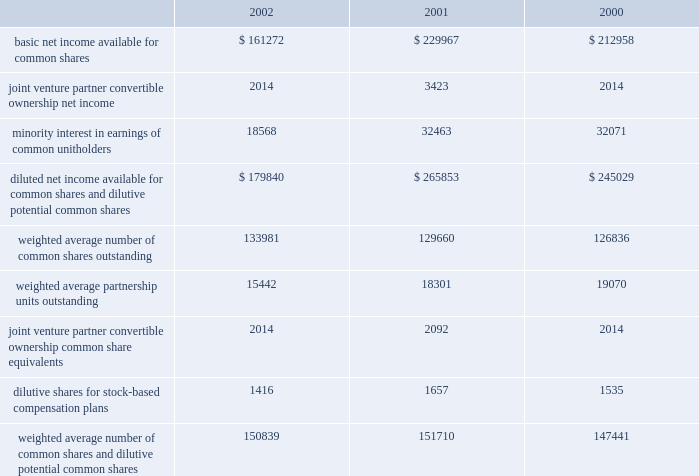D u k e r e a l t y c o r p o r a t i o n 2 8 2 0 0 2 a n n u a l r e p o r t notes to consolidated financial statements the company recognizes income on long-term construction contracts where the company serves as a general contractor on the percentage of completion method .
Using this method , profits are recorded on the basis of the company 2019s estimates of the percentage of completion of individual contracts , commencing when progress reaches a point where experience is sufficient to estimate final results with reasonable accuracy .
That portion of the estimated earnings is accrued on the basis of the company 2019s estimates of the percentage of completion based on contract expenditures incurred and work performed .
Property sales gains from sales of depreciated property are recognized in accordance with statement of financial accounting standards ( 201csfas 201d ) no .
66 , and are included in earnings from sales of land and depreciable property dispositions , net of impairment adjustment , in the statement of operations if identified as held for sale prior to adoption of sfas 144 and in discontinued operations if identified as held for sale after adoption of sfas 144 .
Gains or losses from the sale of property which is considered held for sale in dclp are recognized in accordance with sfas 66 and are included in construction management and development activity income in the statement of operations .
Net income per common share basic net income per common share is computed by dividing net income available for common shares by the weighted average number of common shares outstanding for the period .
Diluted net income per share is computed by dividing the sum of net income available for common shares and minority interest in earnings of unitholders , by the sum of the weighted average number of common shares and units outstanding and dilutive potential common shares for the period .
The table reconciles the components of basic and diluted net income per share ( in thousands ) : the series d convertible preferred stock and the series g convertible preferred limited partner units were anti-dilutive for the years ended december 31 , 2002 , 2001 and 2000 ; therefore , no conversion to common shares is included in weighted dilutive potential common shares .
In september 2002 , the company redeemed the series g convertible preferred units at their par value of $ 35.0 million .
A joint venture partner in one of the company 2019s unconsolidated companies has the option to convert a portion of its ownership to company common shares ( see discussion in investments in unconsolidated companies section ) .
The effect of the option on earnings per share was dilutive for the year ended december 31 , 2001 ; therefore , conversion to common shares is included in weighted dilutive potential common shares .
Federal income taxes the company has elected to be taxed as a real estate investment trust ( 201creit 201d ) under the internal revenue code .
To qualify as a reit , the company must meet a number of organizational and operational requirements , including a requirement that it currently distribute at least 90% ( 90 % ) of its taxable income to its stockholders .
Management intends to continue to adhere to these requirements and to maintain the company 2019s reit status .
As a reit , the company is entitled to a tax deduction for some or all of the dividends it pays to its shareholders .
Accordingly , the company generally will not be subject to federal income taxes as long as it distributes an amount equal to or in excess of its taxable income currently to its stockholders .
A reit generally is subject to federal income taxes on any taxable income that is not currently distributed to its shareholders .
If the company fails to qualify as a reit in any taxable year , it will be subject to federal income taxes and may not be able to qualify as a reit for four subsequent taxable years .
Reit qualification reduces , but does not eliminate , the amount of state and local taxes paid by the company .
In addition , the company 2019s financial statements include the operations of taxable corporate subsidiaries that are not entitled to a dividends paid deduction and are subject to corporate federal , state and local income taxes .
As a reit , the company may also be subject to certain federal excise taxes if it engages in certain types of transactions. .

What is the percent change in basic net income available for common shares from 2001 to 2002? 
Computations: (((229967 - 161272) / 161272) * 100)
Answer: 42.59574. D u k e r e a l t y c o r p o r a t i o n 2 8 2 0 0 2 a n n u a l r e p o r t notes to consolidated financial statements the company recognizes income on long-term construction contracts where the company serves as a general contractor on the percentage of completion method .
Using this method , profits are recorded on the basis of the company 2019s estimates of the percentage of completion of individual contracts , commencing when progress reaches a point where experience is sufficient to estimate final results with reasonable accuracy .
That portion of the estimated earnings is accrued on the basis of the company 2019s estimates of the percentage of completion based on contract expenditures incurred and work performed .
Property sales gains from sales of depreciated property are recognized in accordance with statement of financial accounting standards ( 201csfas 201d ) no .
66 , and are included in earnings from sales of land and depreciable property dispositions , net of impairment adjustment , in the statement of operations if identified as held for sale prior to adoption of sfas 144 and in discontinued operations if identified as held for sale after adoption of sfas 144 .
Gains or losses from the sale of property which is considered held for sale in dclp are recognized in accordance with sfas 66 and are included in construction management and development activity income in the statement of operations .
Net income per common share basic net income per common share is computed by dividing net income available for common shares by the weighted average number of common shares outstanding for the period .
Diluted net income per share is computed by dividing the sum of net income available for common shares and minority interest in earnings of unitholders , by the sum of the weighted average number of common shares and units outstanding and dilutive potential common shares for the period .
The table reconciles the components of basic and diluted net income per share ( in thousands ) : the series d convertible preferred stock and the series g convertible preferred limited partner units were anti-dilutive for the years ended december 31 , 2002 , 2001 and 2000 ; therefore , no conversion to common shares is included in weighted dilutive potential common shares .
In september 2002 , the company redeemed the series g convertible preferred units at their par value of $ 35.0 million .
A joint venture partner in one of the company 2019s unconsolidated companies has the option to convert a portion of its ownership to company common shares ( see discussion in investments in unconsolidated companies section ) .
The effect of the option on earnings per share was dilutive for the year ended december 31 , 2001 ; therefore , conversion to common shares is included in weighted dilutive potential common shares .
Federal income taxes the company has elected to be taxed as a real estate investment trust ( 201creit 201d ) under the internal revenue code .
To qualify as a reit , the company must meet a number of organizational and operational requirements , including a requirement that it currently distribute at least 90% ( 90 % ) of its taxable income to its stockholders .
Management intends to continue to adhere to these requirements and to maintain the company 2019s reit status .
As a reit , the company is entitled to a tax deduction for some or all of the dividends it pays to its shareholders .
Accordingly , the company generally will not be subject to federal income taxes as long as it distributes an amount equal to or in excess of its taxable income currently to its stockholders .
A reit generally is subject to federal income taxes on any taxable income that is not currently distributed to its shareholders .
If the company fails to qualify as a reit in any taxable year , it will be subject to federal income taxes and may not be able to qualify as a reit for four subsequent taxable years .
Reit qualification reduces , but does not eliminate , the amount of state and local taxes paid by the company .
In addition , the company 2019s financial statements include the operations of taxable corporate subsidiaries that are not entitled to a dividends paid deduction and are subject to corporate federal , state and local income taxes .
As a reit , the company may also be subject to certain federal excise taxes if it engages in certain types of transactions. .

The weighted average number of common shares outstanding comprises what percent of weighted average number of common shares and dilutive potential common shares in the year 2001? 
Computations: ((129660 / 151710) * 100)
Answer: 85.46569. 